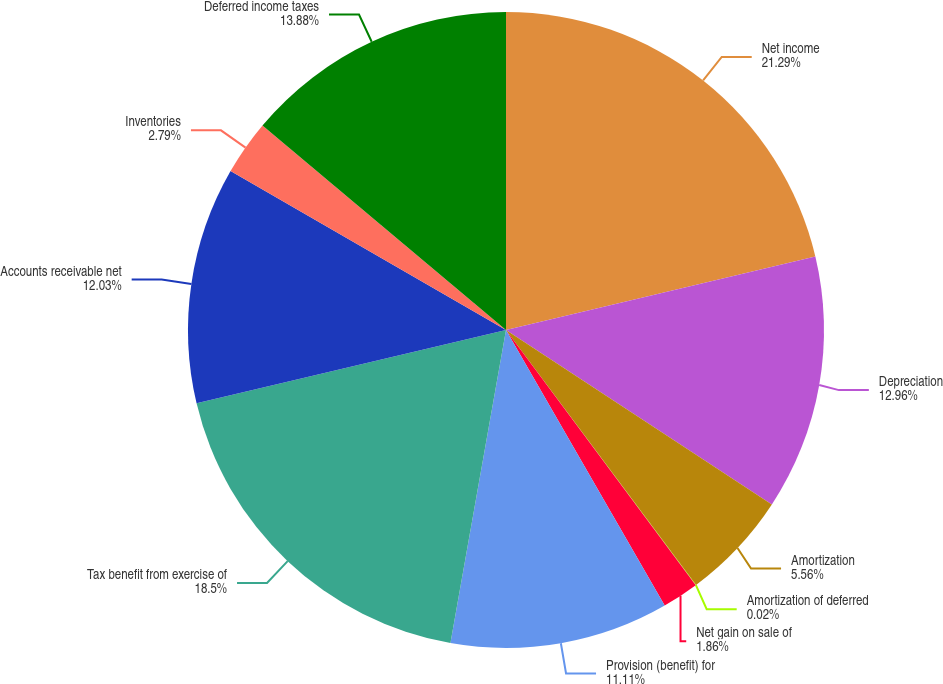Convert chart. <chart><loc_0><loc_0><loc_500><loc_500><pie_chart><fcel>Net income<fcel>Depreciation<fcel>Amortization<fcel>Amortization of deferred<fcel>Net gain on sale of<fcel>Provision (benefit) for<fcel>Tax benefit from exercise of<fcel>Accounts receivable net<fcel>Inventories<fcel>Deferred income taxes<nl><fcel>21.28%<fcel>12.96%<fcel>5.56%<fcel>0.02%<fcel>1.86%<fcel>11.11%<fcel>18.5%<fcel>12.03%<fcel>2.79%<fcel>13.88%<nl></chart> 